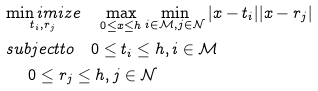Convert formula to latex. <formula><loc_0><loc_0><loc_500><loc_500>& \underset { t _ { i } , r _ { j } } { \min i m i z e } \quad \max _ { 0 \leq x \leq h } \min _ { i \in \mathcal { M } , j \in \mathcal { N } } | x - t _ { i } | | x - r _ { j } | \\ & s u b j e c t t o \quad 0 \leq t _ { i } \leq h , i \in \mathcal { M } \\ & \quad \ 0 \leq r _ { j } \leq h , j \in \mathcal { N }</formula> 